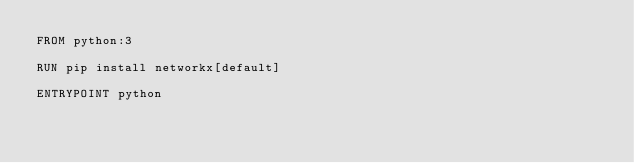Convert code to text. <code><loc_0><loc_0><loc_500><loc_500><_Dockerfile_>FROM python:3

RUN pip install networkx[default]

ENTRYPOINT python
</code> 